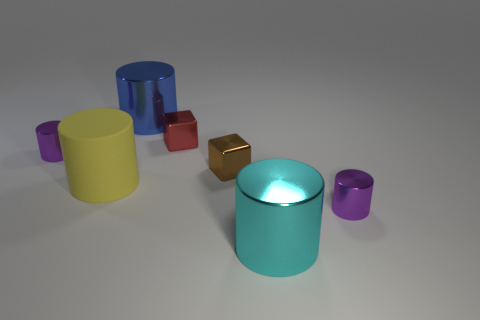Is there any other thing that is the same material as the yellow cylinder?
Ensure brevity in your answer.  No. How many cyan cylinders are the same size as the brown thing?
Keep it short and to the point. 0. What number of yellow rubber cylinders are there?
Your answer should be very brief. 1. Does the large blue object have the same material as the tiny purple cylinder to the left of the big blue metal cylinder?
Your response must be concise. Yes. How many green things are small matte things or tiny metal cylinders?
Offer a terse response. 0. The blue object that is the same material as the red cube is what size?
Provide a succinct answer. Large. How many other small brown shiny objects have the same shape as the brown shiny object?
Offer a very short reply. 0. Is the number of big matte cylinders that are in front of the small brown object greater than the number of blue cylinders on the right side of the red object?
Give a very brief answer. Yes. There is a matte cylinder; is it the same color as the large thing that is behind the red thing?
Ensure brevity in your answer.  No. There is a cyan thing that is the same size as the blue object; what is its material?
Your response must be concise. Metal. 